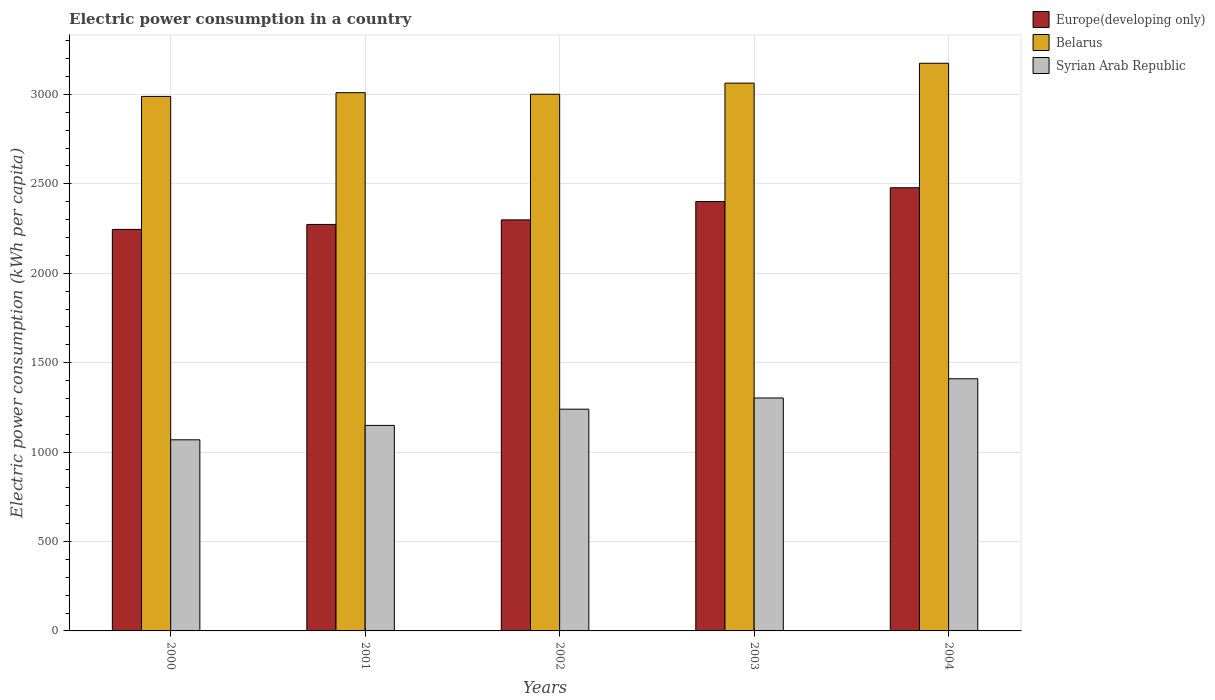How many different coloured bars are there?
Provide a short and direct response. 3. How many groups of bars are there?
Your response must be concise. 5. Are the number of bars per tick equal to the number of legend labels?
Your answer should be compact. Yes. What is the electric power consumption in in Belarus in 2000?
Offer a very short reply. 2988.71. Across all years, what is the maximum electric power consumption in in Europe(developing only)?
Keep it short and to the point. 2477.96. Across all years, what is the minimum electric power consumption in in Syrian Arab Republic?
Your answer should be very brief. 1068.6. In which year was the electric power consumption in in Belarus minimum?
Ensure brevity in your answer.  2000. What is the total electric power consumption in in Syrian Arab Republic in the graph?
Provide a succinct answer. 6169.99. What is the difference between the electric power consumption in in Belarus in 2000 and that in 2001?
Offer a very short reply. -20.86. What is the difference between the electric power consumption in in Syrian Arab Republic in 2003 and the electric power consumption in in Belarus in 2002?
Provide a short and direct response. -1698.41. What is the average electric power consumption in in Europe(developing only) per year?
Your response must be concise. 2339.1. In the year 2004, what is the difference between the electric power consumption in in Europe(developing only) and electric power consumption in in Syrian Arab Republic?
Provide a succinct answer. 1068.09. In how many years, is the electric power consumption in in Belarus greater than 1300 kWh per capita?
Provide a succinct answer. 5. What is the ratio of the electric power consumption in in Syrian Arab Republic in 2000 to that in 2002?
Offer a very short reply. 0.86. Is the difference between the electric power consumption in in Europe(developing only) in 2000 and 2004 greater than the difference between the electric power consumption in in Syrian Arab Republic in 2000 and 2004?
Make the answer very short. Yes. What is the difference between the highest and the second highest electric power consumption in in Syrian Arab Republic?
Your response must be concise. 107.36. What is the difference between the highest and the lowest electric power consumption in in Belarus?
Keep it short and to the point. 185.4. Is the sum of the electric power consumption in in Belarus in 2000 and 2001 greater than the maximum electric power consumption in in Europe(developing only) across all years?
Offer a very short reply. Yes. What does the 1st bar from the left in 2003 represents?
Ensure brevity in your answer.  Europe(developing only). What does the 2nd bar from the right in 2000 represents?
Ensure brevity in your answer.  Belarus. How many bars are there?
Provide a succinct answer. 15. How many years are there in the graph?
Provide a short and direct response. 5. What is the difference between two consecutive major ticks on the Y-axis?
Ensure brevity in your answer.  500. Are the values on the major ticks of Y-axis written in scientific E-notation?
Make the answer very short. No. Does the graph contain any zero values?
Your answer should be compact. No. Where does the legend appear in the graph?
Provide a short and direct response. Top right. How many legend labels are there?
Offer a very short reply. 3. What is the title of the graph?
Provide a succinct answer. Electric power consumption in a country. Does "Singapore" appear as one of the legend labels in the graph?
Ensure brevity in your answer.  No. What is the label or title of the X-axis?
Ensure brevity in your answer.  Years. What is the label or title of the Y-axis?
Your answer should be compact. Electric power consumption (kWh per capita). What is the Electric power consumption (kWh per capita) in Europe(developing only) in 2000?
Your response must be concise. 2245.15. What is the Electric power consumption (kWh per capita) of Belarus in 2000?
Provide a succinct answer. 2988.71. What is the Electric power consumption (kWh per capita) in Syrian Arab Republic in 2000?
Ensure brevity in your answer.  1068.6. What is the Electric power consumption (kWh per capita) of Europe(developing only) in 2001?
Make the answer very short. 2272.95. What is the Electric power consumption (kWh per capita) in Belarus in 2001?
Provide a short and direct response. 3009.57. What is the Electric power consumption (kWh per capita) of Syrian Arab Republic in 2001?
Your response must be concise. 1149.13. What is the Electric power consumption (kWh per capita) in Europe(developing only) in 2002?
Offer a very short reply. 2298.36. What is the Electric power consumption (kWh per capita) of Belarus in 2002?
Make the answer very short. 3000.91. What is the Electric power consumption (kWh per capita) in Syrian Arab Republic in 2002?
Make the answer very short. 1239.89. What is the Electric power consumption (kWh per capita) of Europe(developing only) in 2003?
Provide a succinct answer. 2401.05. What is the Electric power consumption (kWh per capita) in Belarus in 2003?
Your answer should be very brief. 3062.98. What is the Electric power consumption (kWh per capita) in Syrian Arab Republic in 2003?
Offer a terse response. 1302.51. What is the Electric power consumption (kWh per capita) of Europe(developing only) in 2004?
Your answer should be very brief. 2477.96. What is the Electric power consumption (kWh per capita) of Belarus in 2004?
Provide a short and direct response. 3174.1. What is the Electric power consumption (kWh per capita) of Syrian Arab Republic in 2004?
Give a very brief answer. 1409.86. Across all years, what is the maximum Electric power consumption (kWh per capita) in Europe(developing only)?
Offer a very short reply. 2477.96. Across all years, what is the maximum Electric power consumption (kWh per capita) in Belarus?
Your response must be concise. 3174.1. Across all years, what is the maximum Electric power consumption (kWh per capita) in Syrian Arab Republic?
Your answer should be very brief. 1409.86. Across all years, what is the minimum Electric power consumption (kWh per capita) in Europe(developing only)?
Offer a terse response. 2245.15. Across all years, what is the minimum Electric power consumption (kWh per capita) of Belarus?
Make the answer very short. 2988.71. Across all years, what is the minimum Electric power consumption (kWh per capita) in Syrian Arab Republic?
Your answer should be compact. 1068.6. What is the total Electric power consumption (kWh per capita) of Europe(developing only) in the graph?
Offer a very short reply. 1.17e+04. What is the total Electric power consumption (kWh per capita) of Belarus in the graph?
Offer a terse response. 1.52e+04. What is the total Electric power consumption (kWh per capita) of Syrian Arab Republic in the graph?
Your answer should be very brief. 6169.99. What is the difference between the Electric power consumption (kWh per capita) in Europe(developing only) in 2000 and that in 2001?
Make the answer very short. -27.8. What is the difference between the Electric power consumption (kWh per capita) in Belarus in 2000 and that in 2001?
Provide a short and direct response. -20.86. What is the difference between the Electric power consumption (kWh per capita) in Syrian Arab Republic in 2000 and that in 2001?
Keep it short and to the point. -80.52. What is the difference between the Electric power consumption (kWh per capita) in Europe(developing only) in 2000 and that in 2002?
Keep it short and to the point. -53.21. What is the difference between the Electric power consumption (kWh per capita) in Belarus in 2000 and that in 2002?
Your answer should be compact. -12.21. What is the difference between the Electric power consumption (kWh per capita) in Syrian Arab Republic in 2000 and that in 2002?
Your answer should be very brief. -171.28. What is the difference between the Electric power consumption (kWh per capita) in Europe(developing only) in 2000 and that in 2003?
Offer a very short reply. -155.9. What is the difference between the Electric power consumption (kWh per capita) in Belarus in 2000 and that in 2003?
Offer a terse response. -74.27. What is the difference between the Electric power consumption (kWh per capita) of Syrian Arab Republic in 2000 and that in 2003?
Ensure brevity in your answer.  -233.9. What is the difference between the Electric power consumption (kWh per capita) in Europe(developing only) in 2000 and that in 2004?
Provide a short and direct response. -232.81. What is the difference between the Electric power consumption (kWh per capita) in Belarus in 2000 and that in 2004?
Your answer should be very brief. -185.4. What is the difference between the Electric power consumption (kWh per capita) in Syrian Arab Republic in 2000 and that in 2004?
Offer a very short reply. -341.26. What is the difference between the Electric power consumption (kWh per capita) in Europe(developing only) in 2001 and that in 2002?
Keep it short and to the point. -25.41. What is the difference between the Electric power consumption (kWh per capita) of Belarus in 2001 and that in 2002?
Keep it short and to the point. 8.66. What is the difference between the Electric power consumption (kWh per capita) in Syrian Arab Republic in 2001 and that in 2002?
Offer a very short reply. -90.76. What is the difference between the Electric power consumption (kWh per capita) of Europe(developing only) in 2001 and that in 2003?
Provide a short and direct response. -128.1. What is the difference between the Electric power consumption (kWh per capita) in Belarus in 2001 and that in 2003?
Make the answer very short. -53.41. What is the difference between the Electric power consumption (kWh per capita) of Syrian Arab Republic in 2001 and that in 2003?
Your response must be concise. -153.38. What is the difference between the Electric power consumption (kWh per capita) in Europe(developing only) in 2001 and that in 2004?
Your response must be concise. -205.01. What is the difference between the Electric power consumption (kWh per capita) in Belarus in 2001 and that in 2004?
Offer a very short reply. -164.53. What is the difference between the Electric power consumption (kWh per capita) in Syrian Arab Republic in 2001 and that in 2004?
Provide a short and direct response. -260.74. What is the difference between the Electric power consumption (kWh per capita) in Europe(developing only) in 2002 and that in 2003?
Offer a very short reply. -102.69. What is the difference between the Electric power consumption (kWh per capita) in Belarus in 2002 and that in 2003?
Make the answer very short. -62.07. What is the difference between the Electric power consumption (kWh per capita) in Syrian Arab Republic in 2002 and that in 2003?
Your answer should be very brief. -62.62. What is the difference between the Electric power consumption (kWh per capita) in Europe(developing only) in 2002 and that in 2004?
Make the answer very short. -179.6. What is the difference between the Electric power consumption (kWh per capita) of Belarus in 2002 and that in 2004?
Your answer should be very brief. -173.19. What is the difference between the Electric power consumption (kWh per capita) in Syrian Arab Republic in 2002 and that in 2004?
Provide a short and direct response. -169.98. What is the difference between the Electric power consumption (kWh per capita) of Europe(developing only) in 2003 and that in 2004?
Provide a short and direct response. -76.9. What is the difference between the Electric power consumption (kWh per capita) in Belarus in 2003 and that in 2004?
Your response must be concise. -111.12. What is the difference between the Electric power consumption (kWh per capita) in Syrian Arab Republic in 2003 and that in 2004?
Give a very brief answer. -107.36. What is the difference between the Electric power consumption (kWh per capita) in Europe(developing only) in 2000 and the Electric power consumption (kWh per capita) in Belarus in 2001?
Provide a short and direct response. -764.42. What is the difference between the Electric power consumption (kWh per capita) of Europe(developing only) in 2000 and the Electric power consumption (kWh per capita) of Syrian Arab Republic in 2001?
Provide a short and direct response. 1096.03. What is the difference between the Electric power consumption (kWh per capita) of Belarus in 2000 and the Electric power consumption (kWh per capita) of Syrian Arab Republic in 2001?
Give a very brief answer. 1839.58. What is the difference between the Electric power consumption (kWh per capita) of Europe(developing only) in 2000 and the Electric power consumption (kWh per capita) of Belarus in 2002?
Make the answer very short. -755.76. What is the difference between the Electric power consumption (kWh per capita) of Europe(developing only) in 2000 and the Electric power consumption (kWh per capita) of Syrian Arab Republic in 2002?
Make the answer very short. 1005.27. What is the difference between the Electric power consumption (kWh per capita) of Belarus in 2000 and the Electric power consumption (kWh per capita) of Syrian Arab Republic in 2002?
Ensure brevity in your answer.  1748.82. What is the difference between the Electric power consumption (kWh per capita) in Europe(developing only) in 2000 and the Electric power consumption (kWh per capita) in Belarus in 2003?
Your answer should be very brief. -817.83. What is the difference between the Electric power consumption (kWh per capita) of Europe(developing only) in 2000 and the Electric power consumption (kWh per capita) of Syrian Arab Republic in 2003?
Your response must be concise. 942.65. What is the difference between the Electric power consumption (kWh per capita) in Belarus in 2000 and the Electric power consumption (kWh per capita) in Syrian Arab Republic in 2003?
Offer a very short reply. 1686.2. What is the difference between the Electric power consumption (kWh per capita) in Europe(developing only) in 2000 and the Electric power consumption (kWh per capita) in Belarus in 2004?
Give a very brief answer. -928.95. What is the difference between the Electric power consumption (kWh per capita) of Europe(developing only) in 2000 and the Electric power consumption (kWh per capita) of Syrian Arab Republic in 2004?
Provide a succinct answer. 835.29. What is the difference between the Electric power consumption (kWh per capita) in Belarus in 2000 and the Electric power consumption (kWh per capita) in Syrian Arab Republic in 2004?
Your answer should be compact. 1578.84. What is the difference between the Electric power consumption (kWh per capita) of Europe(developing only) in 2001 and the Electric power consumption (kWh per capita) of Belarus in 2002?
Make the answer very short. -727.96. What is the difference between the Electric power consumption (kWh per capita) of Europe(developing only) in 2001 and the Electric power consumption (kWh per capita) of Syrian Arab Republic in 2002?
Keep it short and to the point. 1033.06. What is the difference between the Electric power consumption (kWh per capita) in Belarus in 2001 and the Electric power consumption (kWh per capita) in Syrian Arab Republic in 2002?
Your answer should be very brief. 1769.68. What is the difference between the Electric power consumption (kWh per capita) in Europe(developing only) in 2001 and the Electric power consumption (kWh per capita) in Belarus in 2003?
Make the answer very short. -790.03. What is the difference between the Electric power consumption (kWh per capita) of Europe(developing only) in 2001 and the Electric power consumption (kWh per capita) of Syrian Arab Republic in 2003?
Ensure brevity in your answer.  970.44. What is the difference between the Electric power consumption (kWh per capita) in Belarus in 2001 and the Electric power consumption (kWh per capita) in Syrian Arab Republic in 2003?
Your response must be concise. 1707.06. What is the difference between the Electric power consumption (kWh per capita) of Europe(developing only) in 2001 and the Electric power consumption (kWh per capita) of Belarus in 2004?
Your answer should be compact. -901.15. What is the difference between the Electric power consumption (kWh per capita) of Europe(developing only) in 2001 and the Electric power consumption (kWh per capita) of Syrian Arab Republic in 2004?
Give a very brief answer. 863.09. What is the difference between the Electric power consumption (kWh per capita) in Belarus in 2001 and the Electric power consumption (kWh per capita) in Syrian Arab Republic in 2004?
Provide a short and direct response. 1599.7. What is the difference between the Electric power consumption (kWh per capita) of Europe(developing only) in 2002 and the Electric power consumption (kWh per capita) of Belarus in 2003?
Your answer should be compact. -764.62. What is the difference between the Electric power consumption (kWh per capita) of Europe(developing only) in 2002 and the Electric power consumption (kWh per capita) of Syrian Arab Republic in 2003?
Offer a terse response. 995.86. What is the difference between the Electric power consumption (kWh per capita) in Belarus in 2002 and the Electric power consumption (kWh per capita) in Syrian Arab Republic in 2003?
Your answer should be very brief. 1698.41. What is the difference between the Electric power consumption (kWh per capita) in Europe(developing only) in 2002 and the Electric power consumption (kWh per capita) in Belarus in 2004?
Your response must be concise. -875.74. What is the difference between the Electric power consumption (kWh per capita) in Europe(developing only) in 2002 and the Electric power consumption (kWh per capita) in Syrian Arab Republic in 2004?
Keep it short and to the point. 888.5. What is the difference between the Electric power consumption (kWh per capita) in Belarus in 2002 and the Electric power consumption (kWh per capita) in Syrian Arab Republic in 2004?
Provide a succinct answer. 1591.05. What is the difference between the Electric power consumption (kWh per capita) in Europe(developing only) in 2003 and the Electric power consumption (kWh per capita) in Belarus in 2004?
Ensure brevity in your answer.  -773.05. What is the difference between the Electric power consumption (kWh per capita) of Europe(developing only) in 2003 and the Electric power consumption (kWh per capita) of Syrian Arab Republic in 2004?
Ensure brevity in your answer.  991.19. What is the difference between the Electric power consumption (kWh per capita) in Belarus in 2003 and the Electric power consumption (kWh per capita) in Syrian Arab Republic in 2004?
Offer a very short reply. 1653.11. What is the average Electric power consumption (kWh per capita) of Europe(developing only) per year?
Make the answer very short. 2339.1. What is the average Electric power consumption (kWh per capita) in Belarus per year?
Provide a succinct answer. 3047.25. What is the average Electric power consumption (kWh per capita) of Syrian Arab Republic per year?
Offer a very short reply. 1234. In the year 2000, what is the difference between the Electric power consumption (kWh per capita) of Europe(developing only) and Electric power consumption (kWh per capita) of Belarus?
Offer a terse response. -743.55. In the year 2000, what is the difference between the Electric power consumption (kWh per capita) of Europe(developing only) and Electric power consumption (kWh per capita) of Syrian Arab Republic?
Your answer should be very brief. 1176.55. In the year 2000, what is the difference between the Electric power consumption (kWh per capita) of Belarus and Electric power consumption (kWh per capita) of Syrian Arab Republic?
Provide a short and direct response. 1920.1. In the year 2001, what is the difference between the Electric power consumption (kWh per capita) in Europe(developing only) and Electric power consumption (kWh per capita) in Belarus?
Ensure brevity in your answer.  -736.62. In the year 2001, what is the difference between the Electric power consumption (kWh per capita) of Europe(developing only) and Electric power consumption (kWh per capita) of Syrian Arab Republic?
Your response must be concise. 1123.82. In the year 2001, what is the difference between the Electric power consumption (kWh per capita) of Belarus and Electric power consumption (kWh per capita) of Syrian Arab Republic?
Keep it short and to the point. 1860.44. In the year 2002, what is the difference between the Electric power consumption (kWh per capita) in Europe(developing only) and Electric power consumption (kWh per capita) in Belarus?
Give a very brief answer. -702.55. In the year 2002, what is the difference between the Electric power consumption (kWh per capita) in Europe(developing only) and Electric power consumption (kWh per capita) in Syrian Arab Republic?
Keep it short and to the point. 1058.48. In the year 2002, what is the difference between the Electric power consumption (kWh per capita) in Belarus and Electric power consumption (kWh per capita) in Syrian Arab Republic?
Your answer should be very brief. 1761.03. In the year 2003, what is the difference between the Electric power consumption (kWh per capita) in Europe(developing only) and Electric power consumption (kWh per capita) in Belarus?
Provide a succinct answer. -661.92. In the year 2003, what is the difference between the Electric power consumption (kWh per capita) in Europe(developing only) and Electric power consumption (kWh per capita) in Syrian Arab Republic?
Your answer should be very brief. 1098.55. In the year 2003, what is the difference between the Electric power consumption (kWh per capita) of Belarus and Electric power consumption (kWh per capita) of Syrian Arab Republic?
Provide a short and direct response. 1760.47. In the year 2004, what is the difference between the Electric power consumption (kWh per capita) in Europe(developing only) and Electric power consumption (kWh per capita) in Belarus?
Make the answer very short. -696.14. In the year 2004, what is the difference between the Electric power consumption (kWh per capita) of Europe(developing only) and Electric power consumption (kWh per capita) of Syrian Arab Republic?
Your answer should be compact. 1068.09. In the year 2004, what is the difference between the Electric power consumption (kWh per capita) of Belarus and Electric power consumption (kWh per capita) of Syrian Arab Republic?
Give a very brief answer. 1764.24. What is the ratio of the Electric power consumption (kWh per capita) of Syrian Arab Republic in 2000 to that in 2001?
Your answer should be compact. 0.93. What is the ratio of the Electric power consumption (kWh per capita) in Europe(developing only) in 2000 to that in 2002?
Offer a terse response. 0.98. What is the ratio of the Electric power consumption (kWh per capita) of Syrian Arab Republic in 2000 to that in 2002?
Your answer should be compact. 0.86. What is the ratio of the Electric power consumption (kWh per capita) in Europe(developing only) in 2000 to that in 2003?
Provide a short and direct response. 0.94. What is the ratio of the Electric power consumption (kWh per capita) in Belarus in 2000 to that in 2003?
Make the answer very short. 0.98. What is the ratio of the Electric power consumption (kWh per capita) of Syrian Arab Republic in 2000 to that in 2003?
Keep it short and to the point. 0.82. What is the ratio of the Electric power consumption (kWh per capita) of Europe(developing only) in 2000 to that in 2004?
Offer a terse response. 0.91. What is the ratio of the Electric power consumption (kWh per capita) in Belarus in 2000 to that in 2004?
Keep it short and to the point. 0.94. What is the ratio of the Electric power consumption (kWh per capita) of Syrian Arab Republic in 2000 to that in 2004?
Provide a succinct answer. 0.76. What is the ratio of the Electric power consumption (kWh per capita) of Europe(developing only) in 2001 to that in 2002?
Your answer should be very brief. 0.99. What is the ratio of the Electric power consumption (kWh per capita) in Syrian Arab Republic in 2001 to that in 2002?
Your response must be concise. 0.93. What is the ratio of the Electric power consumption (kWh per capita) in Europe(developing only) in 2001 to that in 2003?
Your response must be concise. 0.95. What is the ratio of the Electric power consumption (kWh per capita) of Belarus in 2001 to that in 2003?
Provide a short and direct response. 0.98. What is the ratio of the Electric power consumption (kWh per capita) in Syrian Arab Republic in 2001 to that in 2003?
Offer a terse response. 0.88. What is the ratio of the Electric power consumption (kWh per capita) in Europe(developing only) in 2001 to that in 2004?
Make the answer very short. 0.92. What is the ratio of the Electric power consumption (kWh per capita) in Belarus in 2001 to that in 2004?
Keep it short and to the point. 0.95. What is the ratio of the Electric power consumption (kWh per capita) of Syrian Arab Republic in 2001 to that in 2004?
Keep it short and to the point. 0.82. What is the ratio of the Electric power consumption (kWh per capita) of Europe(developing only) in 2002 to that in 2003?
Your answer should be very brief. 0.96. What is the ratio of the Electric power consumption (kWh per capita) of Belarus in 2002 to that in 2003?
Provide a short and direct response. 0.98. What is the ratio of the Electric power consumption (kWh per capita) of Syrian Arab Republic in 2002 to that in 2003?
Provide a succinct answer. 0.95. What is the ratio of the Electric power consumption (kWh per capita) of Europe(developing only) in 2002 to that in 2004?
Your answer should be compact. 0.93. What is the ratio of the Electric power consumption (kWh per capita) in Belarus in 2002 to that in 2004?
Your answer should be very brief. 0.95. What is the ratio of the Electric power consumption (kWh per capita) of Syrian Arab Republic in 2002 to that in 2004?
Provide a short and direct response. 0.88. What is the ratio of the Electric power consumption (kWh per capita) in Syrian Arab Republic in 2003 to that in 2004?
Make the answer very short. 0.92. What is the difference between the highest and the second highest Electric power consumption (kWh per capita) of Europe(developing only)?
Provide a succinct answer. 76.9. What is the difference between the highest and the second highest Electric power consumption (kWh per capita) in Belarus?
Offer a terse response. 111.12. What is the difference between the highest and the second highest Electric power consumption (kWh per capita) of Syrian Arab Republic?
Ensure brevity in your answer.  107.36. What is the difference between the highest and the lowest Electric power consumption (kWh per capita) in Europe(developing only)?
Your response must be concise. 232.81. What is the difference between the highest and the lowest Electric power consumption (kWh per capita) in Belarus?
Keep it short and to the point. 185.4. What is the difference between the highest and the lowest Electric power consumption (kWh per capita) of Syrian Arab Republic?
Offer a very short reply. 341.26. 